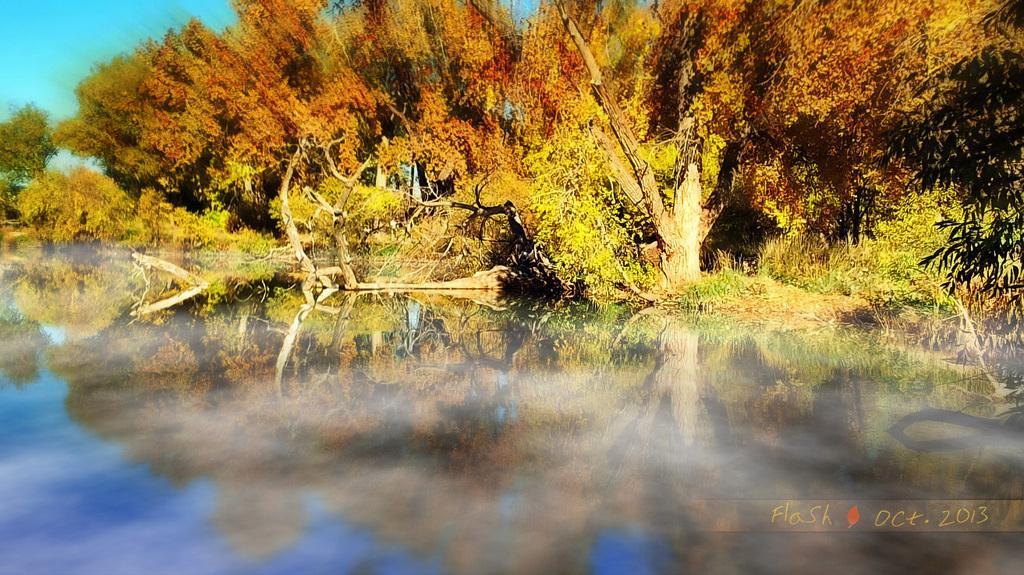How would you summarize this image in a sentence or two? In this image in the background there are trees and there is some text written on the image. 